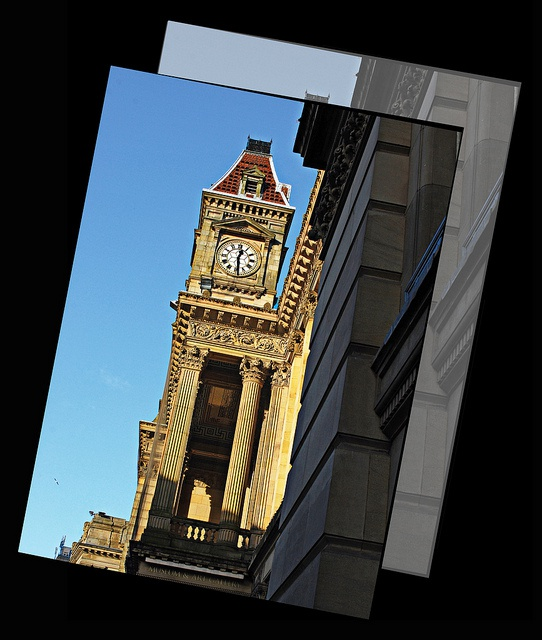Describe the objects in this image and their specific colors. I can see a clock in black, white, darkgray, and khaki tones in this image. 